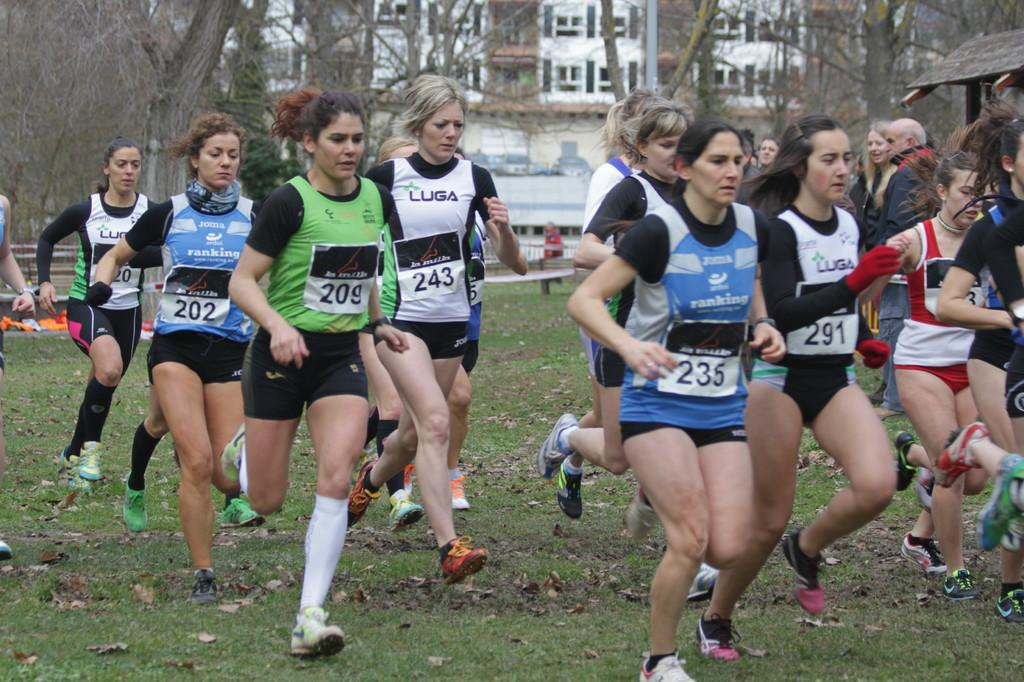<image>
Create a compact narrative representing the image presented. A group of women, all with different numbers on racing tags, pinned to their shirts are running on grass. 